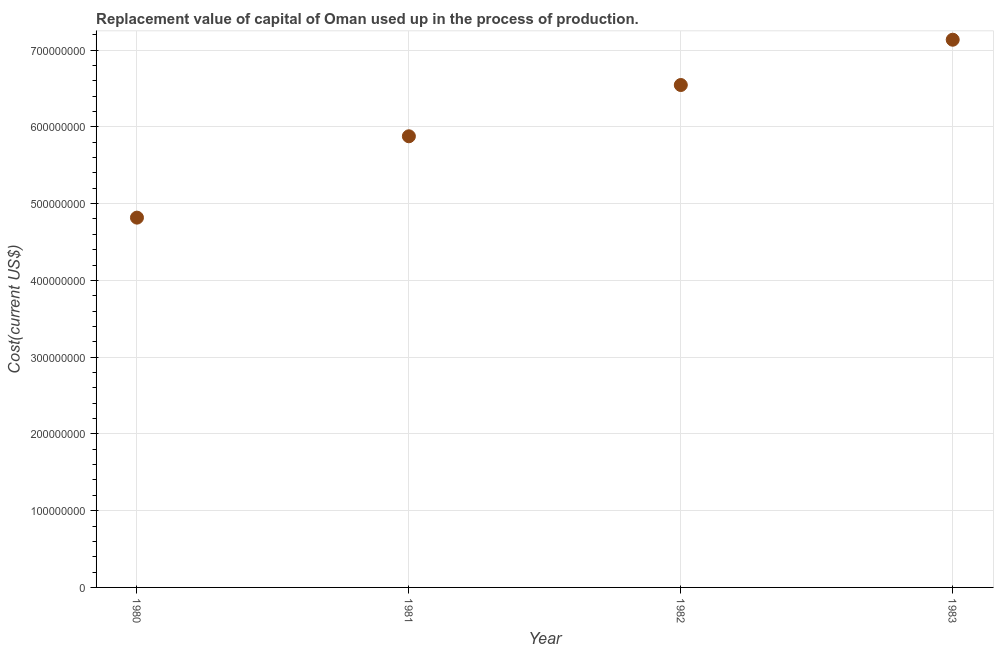What is the consumption of fixed capital in 1980?
Your answer should be very brief. 4.82e+08. Across all years, what is the maximum consumption of fixed capital?
Provide a short and direct response. 7.13e+08. Across all years, what is the minimum consumption of fixed capital?
Offer a very short reply. 4.82e+08. In which year was the consumption of fixed capital maximum?
Give a very brief answer. 1983. In which year was the consumption of fixed capital minimum?
Keep it short and to the point. 1980. What is the sum of the consumption of fixed capital?
Make the answer very short. 2.44e+09. What is the difference between the consumption of fixed capital in 1981 and 1983?
Ensure brevity in your answer.  -1.26e+08. What is the average consumption of fixed capital per year?
Your answer should be compact. 6.09e+08. What is the median consumption of fixed capital?
Make the answer very short. 6.21e+08. What is the ratio of the consumption of fixed capital in 1981 to that in 1983?
Your response must be concise. 0.82. Is the consumption of fixed capital in 1981 less than that in 1982?
Provide a succinct answer. Yes. What is the difference between the highest and the second highest consumption of fixed capital?
Make the answer very short. 5.90e+07. What is the difference between the highest and the lowest consumption of fixed capital?
Provide a succinct answer. 2.32e+08. In how many years, is the consumption of fixed capital greater than the average consumption of fixed capital taken over all years?
Offer a very short reply. 2. Does the consumption of fixed capital monotonically increase over the years?
Offer a very short reply. Yes. How many dotlines are there?
Your answer should be very brief. 1. How many years are there in the graph?
Offer a terse response. 4. What is the difference between two consecutive major ticks on the Y-axis?
Your answer should be compact. 1.00e+08. Does the graph contain any zero values?
Give a very brief answer. No. What is the title of the graph?
Offer a very short reply. Replacement value of capital of Oman used up in the process of production. What is the label or title of the X-axis?
Your response must be concise. Year. What is the label or title of the Y-axis?
Keep it short and to the point. Cost(current US$). What is the Cost(current US$) in 1980?
Your answer should be compact. 4.82e+08. What is the Cost(current US$) in 1981?
Your answer should be compact. 5.88e+08. What is the Cost(current US$) in 1982?
Your answer should be very brief. 6.54e+08. What is the Cost(current US$) in 1983?
Your response must be concise. 7.13e+08. What is the difference between the Cost(current US$) in 1980 and 1981?
Give a very brief answer. -1.06e+08. What is the difference between the Cost(current US$) in 1980 and 1982?
Your answer should be very brief. -1.73e+08. What is the difference between the Cost(current US$) in 1980 and 1983?
Your answer should be very brief. -2.32e+08. What is the difference between the Cost(current US$) in 1981 and 1982?
Offer a terse response. -6.68e+07. What is the difference between the Cost(current US$) in 1981 and 1983?
Keep it short and to the point. -1.26e+08. What is the difference between the Cost(current US$) in 1982 and 1983?
Keep it short and to the point. -5.90e+07. What is the ratio of the Cost(current US$) in 1980 to that in 1981?
Your answer should be compact. 0.82. What is the ratio of the Cost(current US$) in 1980 to that in 1982?
Give a very brief answer. 0.74. What is the ratio of the Cost(current US$) in 1980 to that in 1983?
Your answer should be very brief. 0.68. What is the ratio of the Cost(current US$) in 1981 to that in 1982?
Provide a succinct answer. 0.9. What is the ratio of the Cost(current US$) in 1981 to that in 1983?
Your answer should be compact. 0.82. What is the ratio of the Cost(current US$) in 1982 to that in 1983?
Make the answer very short. 0.92. 